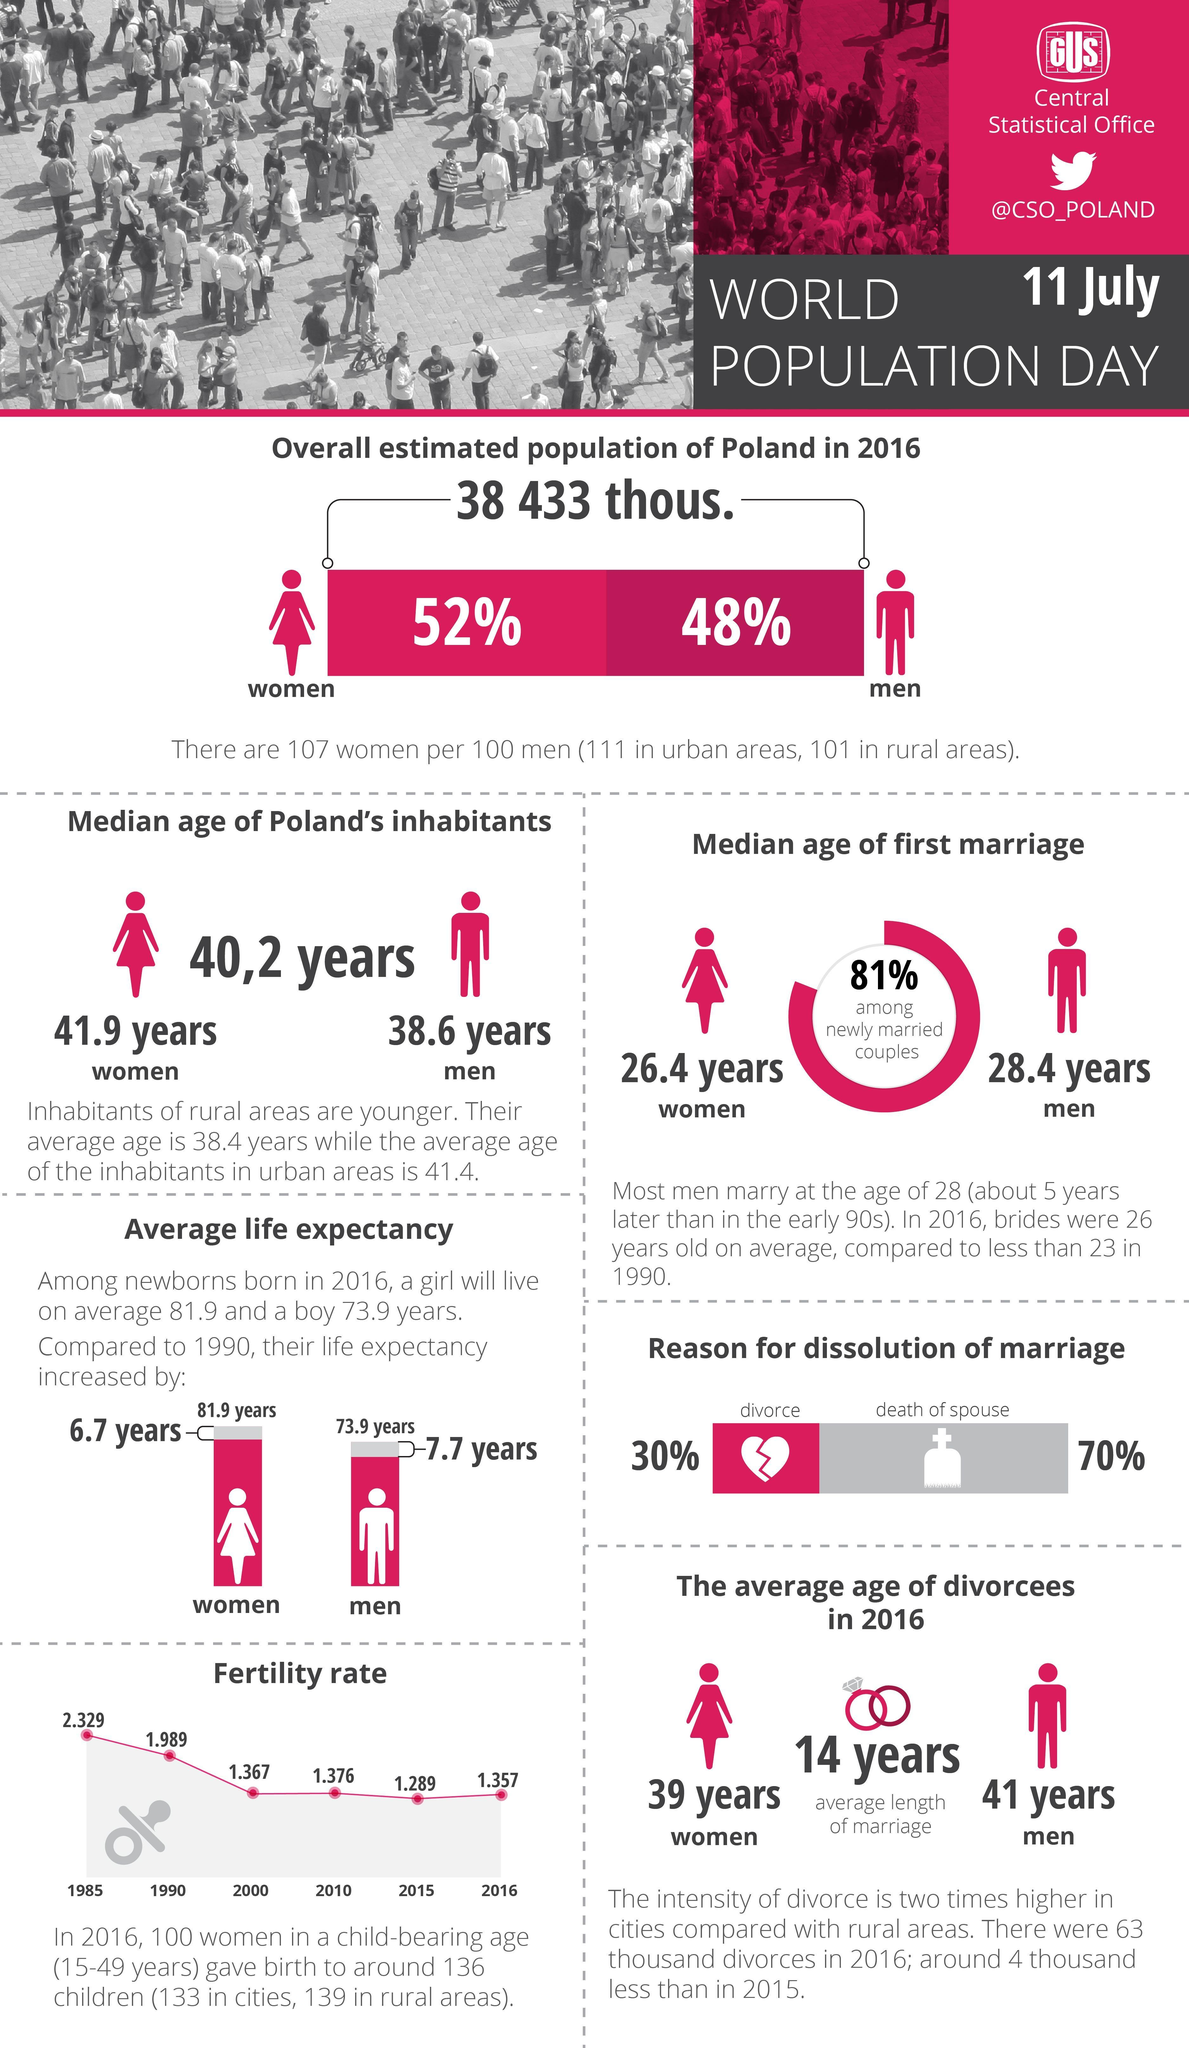What is the life expectancy of a boy born in 1990?
Answer the question with a short phrase. 66.2 What is the fertility rate in 2000 and 2010, taken together? 2.743 What is the life expectancy of a girl born in 1990? 75.2 What is the fertility rate in 1985 and 1990, taken together? 4.318 